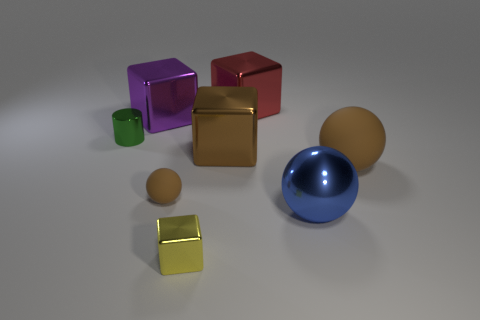Subtract all big purple shiny cubes. How many cubes are left? 3 Subtract all yellow cylinders. How many brown balls are left? 2 Subtract all yellow cubes. How many cubes are left? 3 Subtract 1 blocks. How many blocks are left? 3 Add 1 blue metal spheres. How many objects exist? 9 Subtract 0 gray cubes. How many objects are left? 8 Subtract all cylinders. How many objects are left? 7 Subtract all yellow cylinders. Subtract all gray balls. How many cylinders are left? 1 Subtract all small purple things. Subtract all tiny brown objects. How many objects are left? 7 Add 6 cylinders. How many cylinders are left? 7 